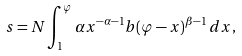Convert formula to latex. <formula><loc_0><loc_0><loc_500><loc_500>s = N \int _ { 1 } ^ { \varphi } \alpha x ^ { - \alpha - 1 } b ( \varphi - x ) ^ { \beta - 1 } \, d x ,</formula> 